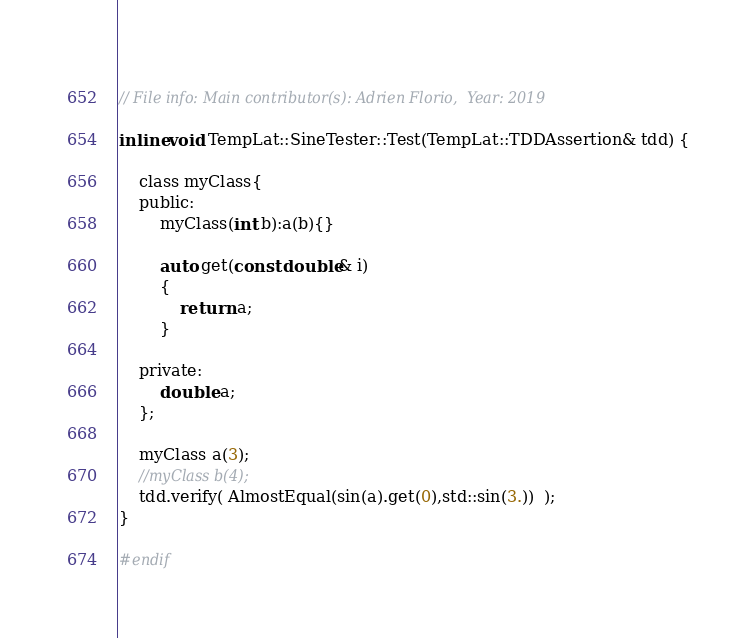<code> <loc_0><loc_0><loc_500><loc_500><_C_>   
// File info: Main contributor(s): Adrien Florio,  Year: 2019

inline void TempLat::SineTester::Test(TempLat::TDDAssertion& tdd) {

    class myClass{
    public:
        myClass(int b):a(b){}

        auto get(const double& i)
        {
            return a;
        }

    private:
        double a;
    };

    myClass a(3);
    //myClass b(4);
    tdd.verify( AlmostEqual(sin(a).get(0),std::sin(3.))  );
}

#endif
</code> 